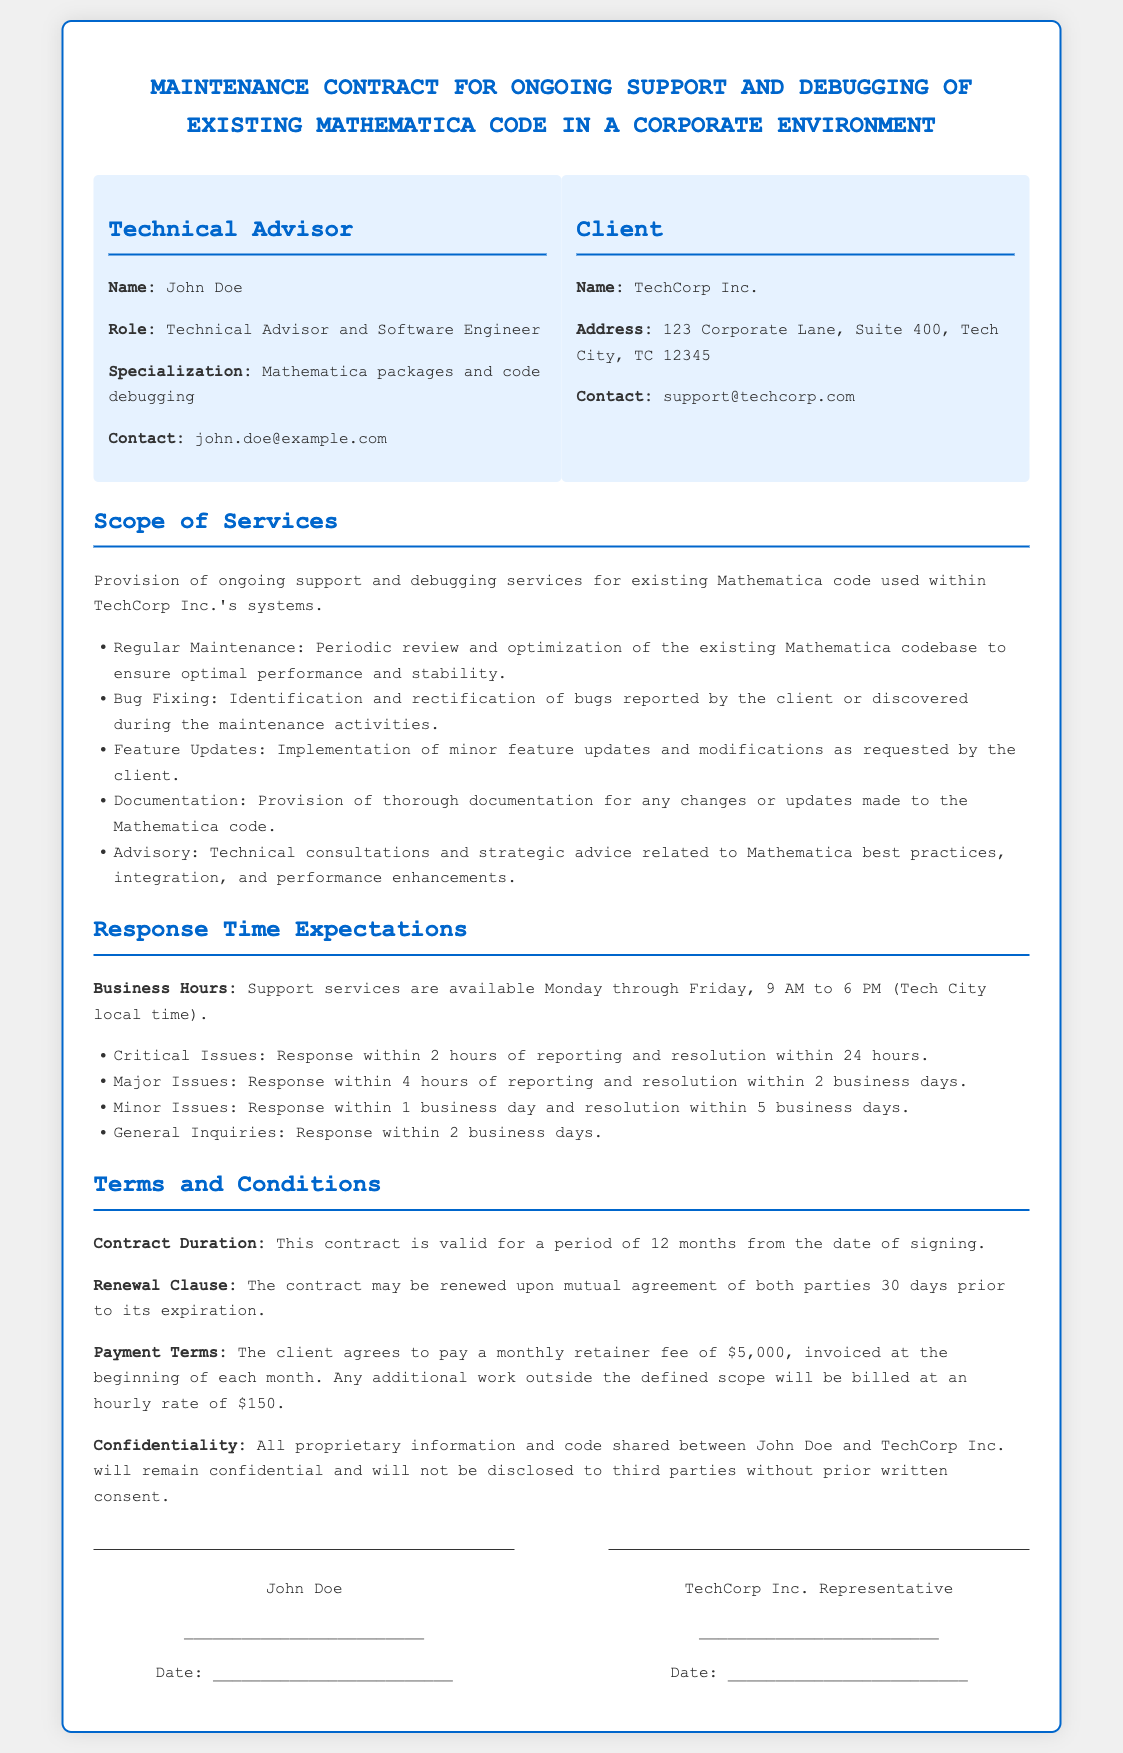what is the name of the technical advisor? The name of the technical advisor is listed in the contract as John Doe.
Answer: John Doe what is the duration of the contract? The contract duration is specified to be valid for a period of 12 months from the date of signing.
Answer: 12 months how much is the monthly retainer fee? The payment terms indicate a monthly retainer fee of $5,000 to be paid at the beginning of each month.
Answer: $5,000 what is the response time for critical issues? The response time expectation for critical issues is stated as within 2 hours of reporting.
Answer: 2 hours which company is the client in the contract? The name of the client company mentioned in the contract is TechCorp Inc.
Answer: TechCorp Inc what is the expected resolution time for major issues? The resolution for major issues is expected within 2 business days as per the response time expectations section.
Answer: 2 business days how many hours of response time are allotted for minor issues? The response time for minor issues is stated to be within 1 business day.
Answer: 1 business day when must the contract be renewed? The contract includes a renewal clause that states it may be renewed 30 days prior to its expiration.
Answer: 30 days prior what type of services are included in the scope? The scope of services includes ongoing support and debugging services for existing Mathematica code.
Answer: Ongoing support and debugging services 